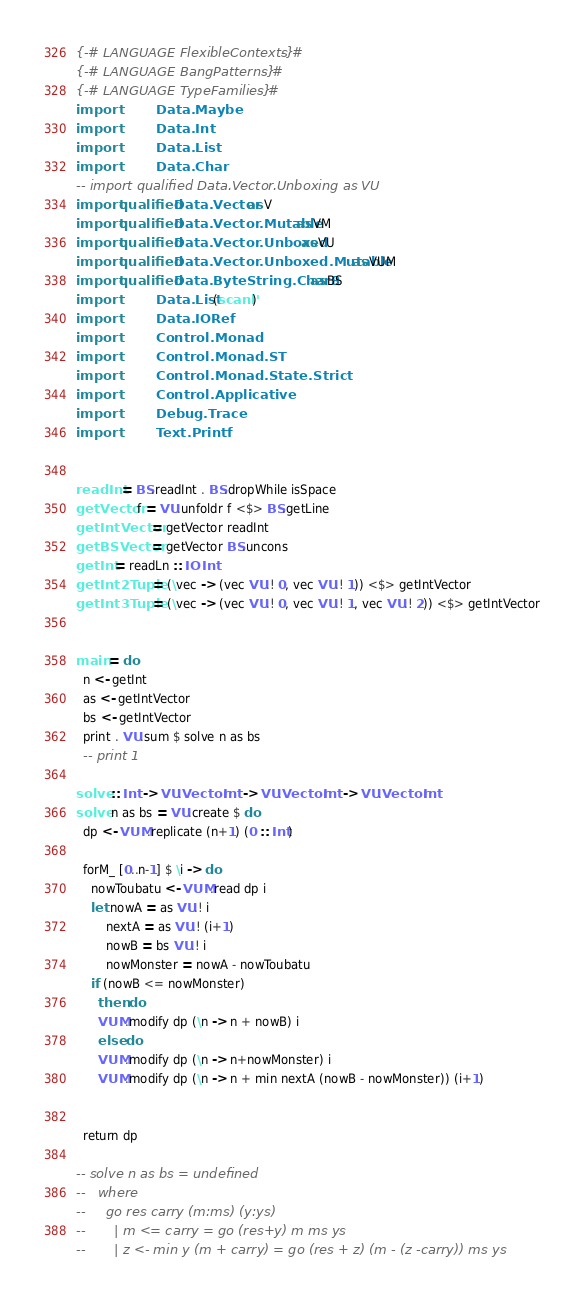<code> <loc_0><loc_0><loc_500><loc_500><_Haskell_>{-# LANGUAGE FlexibleContexts #-}
{-# LANGUAGE BangPatterns #-}
{-# LANGUAGE TypeFamilies #-}
import           Data.Maybe
import           Data.Int
import           Data.List
import           Data.Char
-- import qualified Data.Vector.Unboxing as VU
import qualified Data.Vector as V
import qualified Data.Vector.Mutable as VM
import qualified Data.Vector.Unboxed as VU
import qualified Data.Vector.Unboxed.Mutable as VUM
import qualified Data.ByteString.Char8 as BS
import           Data.List (scanl')
import           Data.IORef
import           Control.Monad
import           Control.Monad.ST
import           Control.Monad.State.Strict
import           Control.Applicative
import           Debug.Trace
import           Text.Printf


readInt = BS.readInt . BS.dropWhile isSpace
getVector f = VU.unfoldr f <$> BS.getLine
getIntVector = getVector readInt
getBSVector = getVector BS.uncons
getInt = readLn :: IO Int
getInt2Tuple = (\vec -> (vec VU.! 0, vec VU.! 1)) <$> getIntVector
getInt3Tuple = (\vec -> (vec VU.! 0, vec VU.! 1, vec VU.! 2)) <$> getIntVector


main = do
  n <- getInt
  as <- getIntVector
  bs <- getIntVector
  print . VU.sum $ solve n as bs
  -- print 1

solve :: Int -> VU.Vector Int -> VU.Vector Int -> VU.Vector Int
solve n as bs = VU.create $ do
  dp <- VUM.replicate (n+1) (0 :: Int)

  forM_ [0..n-1] $ \i -> do
    nowToubatu <- VUM.read dp i
    let nowA = as VU.! i
        nextA = as VU.! (i+1)
        nowB = bs VU.! i
        nowMonster = nowA - nowToubatu
    if (nowB <= nowMonster)
      then do
      VUM.modify dp (\n -> n + nowB) i
      else do
      VUM.modify dp (\n -> n+nowMonster) i
      VUM.modify dp (\n -> n + min nextA (nowB - nowMonster)) (i+1)


  return dp

-- solve n as bs = undefined
--   where
--     go res carry (m:ms) (y:ys)
--       | m <= carry = go (res+y) m ms ys
--       | z <- min y (m + carry) = go (res + z) (m - (z -carry)) ms ys
</code> 